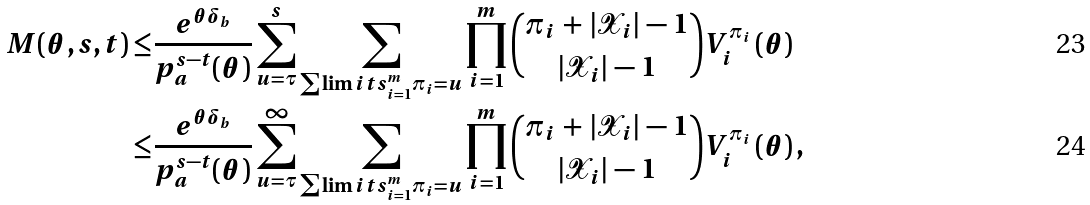<formula> <loc_0><loc_0><loc_500><loc_500>M ( \theta , s , t ) \leq & \frac { e ^ { \theta \delta _ { b } } } { p _ { a } ^ { s - t } ( \theta ) } \sum _ { u = \tau } ^ { s } \sum _ { \sum \lim i t s _ { i = 1 } ^ { m } \pi _ { i } = u } \prod _ { i = 1 } ^ { m } \binom { \pi _ { i } \, + \, | \mathcal { X } _ { i } | \, - \, 1 } { | \mathcal { X } _ { i } | \, - \, 1 } V _ { i } ^ { \pi _ { i } } \left ( \theta \right ) \\ \leq & \frac { e ^ { \theta \delta _ { b } } } { p _ { a } ^ { s - t } ( \theta ) } \sum _ { u = \tau } ^ { \infty } \sum _ { \sum \lim i t s _ { i = 1 } ^ { m } \pi _ { i } = u } \prod _ { i = 1 } ^ { m } \binom { \pi _ { i } \, + \, | \mathcal { X } _ { i } | \, - \, 1 } { | \mathcal { X } _ { i } | \, - \, 1 } V _ { i } ^ { \pi _ { i } } \left ( \theta \right ) ,</formula> 